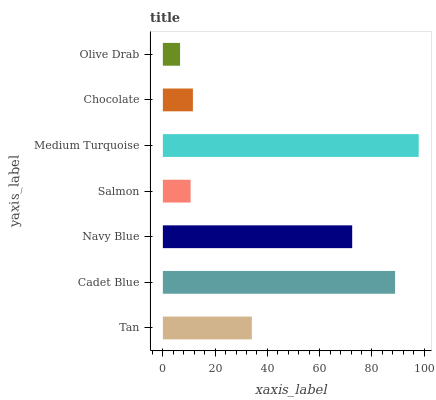Is Olive Drab the minimum?
Answer yes or no. Yes. Is Medium Turquoise the maximum?
Answer yes or no. Yes. Is Cadet Blue the minimum?
Answer yes or no. No. Is Cadet Blue the maximum?
Answer yes or no. No. Is Cadet Blue greater than Tan?
Answer yes or no. Yes. Is Tan less than Cadet Blue?
Answer yes or no. Yes. Is Tan greater than Cadet Blue?
Answer yes or no. No. Is Cadet Blue less than Tan?
Answer yes or no. No. Is Tan the high median?
Answer yes or no. Yes. Is Tan the low median?
Answer yes or no. Yes. Is Navy Blue the high median?
Answer yes or no. No. Is Medium Turquoise the low median?
Answer yes or no. No. 